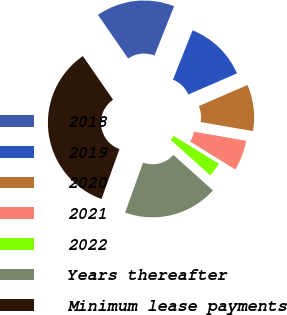Convert chart. <chart><loc_0><loc_0><loc_500><loc_500><pie_chart><fcel>2018<fcel>2019<fcel>2020<fcel>2021<fcel>2022<fcel>Years thereafter<fcel>Minimum lease payments<nl><fcel>15.66%<fcel>12.46%<fcel>9.25%<fcel>6.05%<fcel>2.85%<fcel>18.86%<fcel>34.87%<nl></chart> 